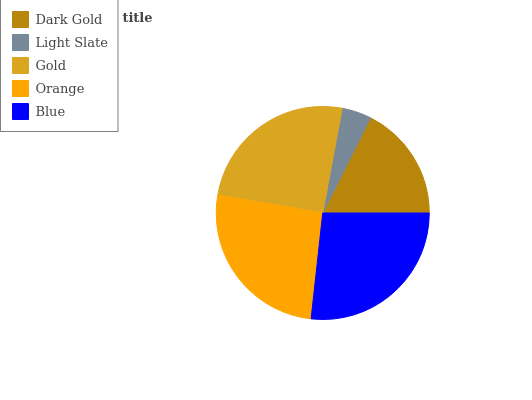Is Light Slate the minimum?
Answer yes or no. Yes. Is Blue the maximum?
Answer yes or no. Yes. Is Gold the minimum?
Answer yes or no. No. Is Gold the maximum?
Answer yes or no. No. Is Gold greater than Light Slate?
Answer yes or no. Yes. Is Light Slate less than Gold?
Answer yes or no. Yes. Is Light Slate greater than Gold?
Answer yes or no. No. Is Gold less than Light Slate?
Answer yes or no. No. Is Gold the high median?
Answer yes or no. Yes. Is Gold the low median?
Answer yes or no. Yes. Is Blue the high median?
Answer yes or no. No. Is Dark Gold the low median?
Answer yes or no. No. 